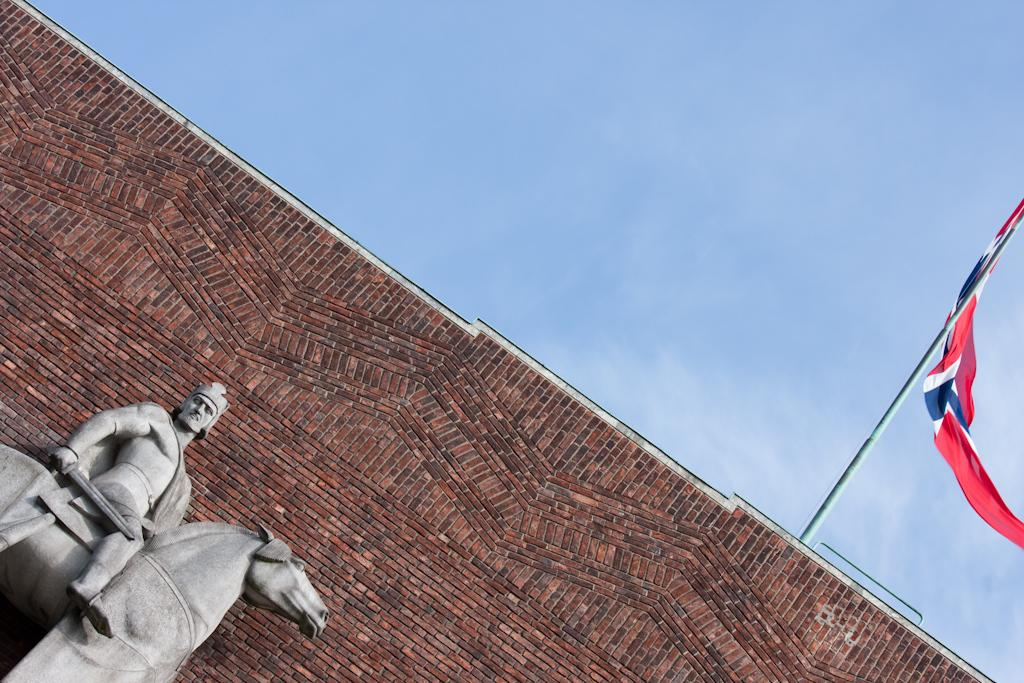What can be seen in the bottom left corner of the image? There is a statue of a person and horse in the bottom left corner of the image. What is located in the center of the image? There is a wall in the center of the image. What is on the right side of the image? There is a pole and flag on the right side of the image. What is visible at the top of the image? The sky is visible at the top of the image. Can you tell me how many light bulbs are hanging from the wall in the image? There are no light bulbs present in the image; it features a statue, a wall, a pole, a flag, and a sky. Is the doctor in the image taking a vacation? There is no doctor or any indication of a vacation in the image. 